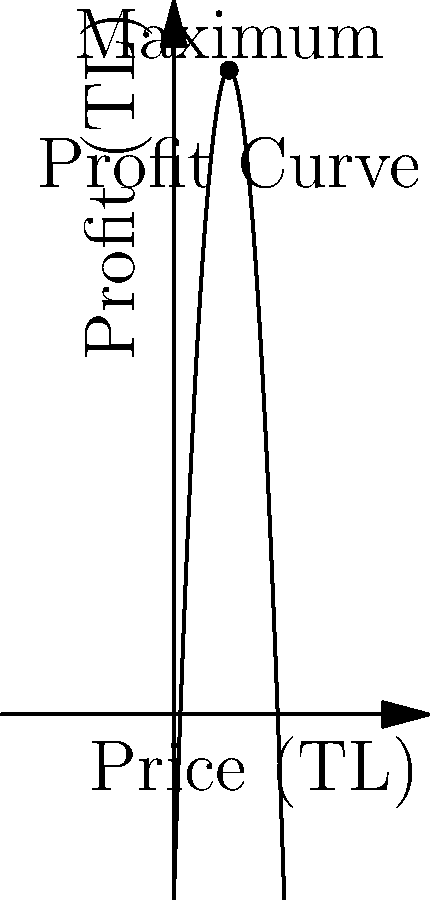As a seller of traditional Turkish carpets, you've modeled your profit (in Turkish Lira) as a function of the price per carpet (also in Turkish Lira). The profit function is given by $P(x) = -0.5x^2 + 30x - 100$, where $x$ is the price per carpet. What price should you set for each carpet to maximize your profit, and what is the maximum profit? To find the maximum profit, we need to follow these steps:

1) The profit function is a quadratic equation: $P(x) = -0.5x^2 + 30x - 100$

2) To find the maximum point, we need to find the vertex of this parabola. For a quadratic function in the form $f(x) = ax^2 + bx + c$, the x-coordinate of the vertex is given by $x = -\frac{b}{2a}$

3) In our case, $a = -0.5$ and $b = 30$. So:

   $x = -\frac{30}{2(-0.5)} = -\frac{30}{-1} = 30$

4) This means the price that maximizes profit is 30 TL per carpet.

5) To find the maximum profit, we substitute this x-value back into the original function:

   $P(30) = -0.5(30)^2 + 30(30) - 100$
          $= -0.5(900) + 900 - 100$
          $= -450 + 900 - 100$
          $= 350$

Therefore, the maximum profit is 350 TL.
Answer: Price: 30 TL, Maximum Profit: 350 TL 